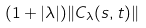<formula> <loc_0><loc_0><loc_500><loc_500>( 1 + | \lambda | ) \| C _ { \lambda } ( s , t ) \|</formula> 